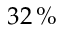<formula> <loc_0><loc_0><loc_500><loc_500>3 2 \, \%</formula> 